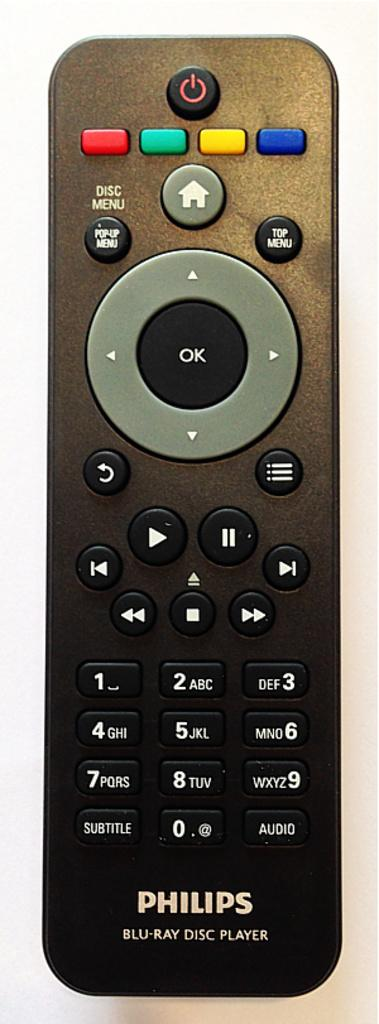<image>
Provide a brief description of the given image. A black Philips remote for a blu ray disc player. 